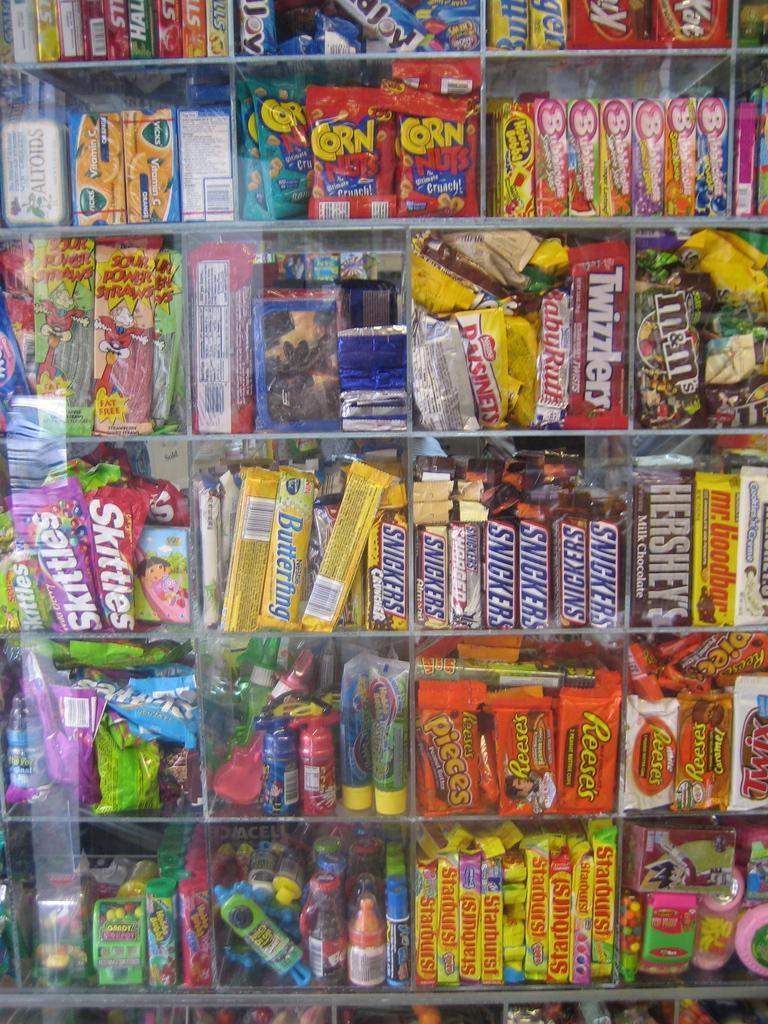<image>
Write a terse but informative summary of the picture. a display of candy including Starburst And Corn Nuts 